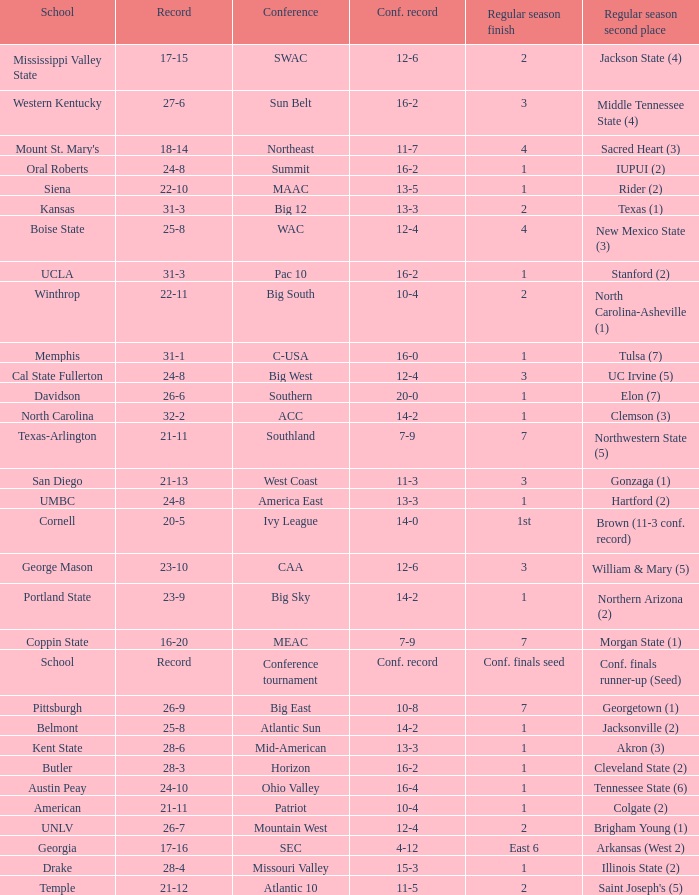Which qualifying schools were in the Patriot conference? American. 